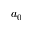<formula> <loc_0><loc_0><loc_500><loc_500>a _ { 0 }</formula> 